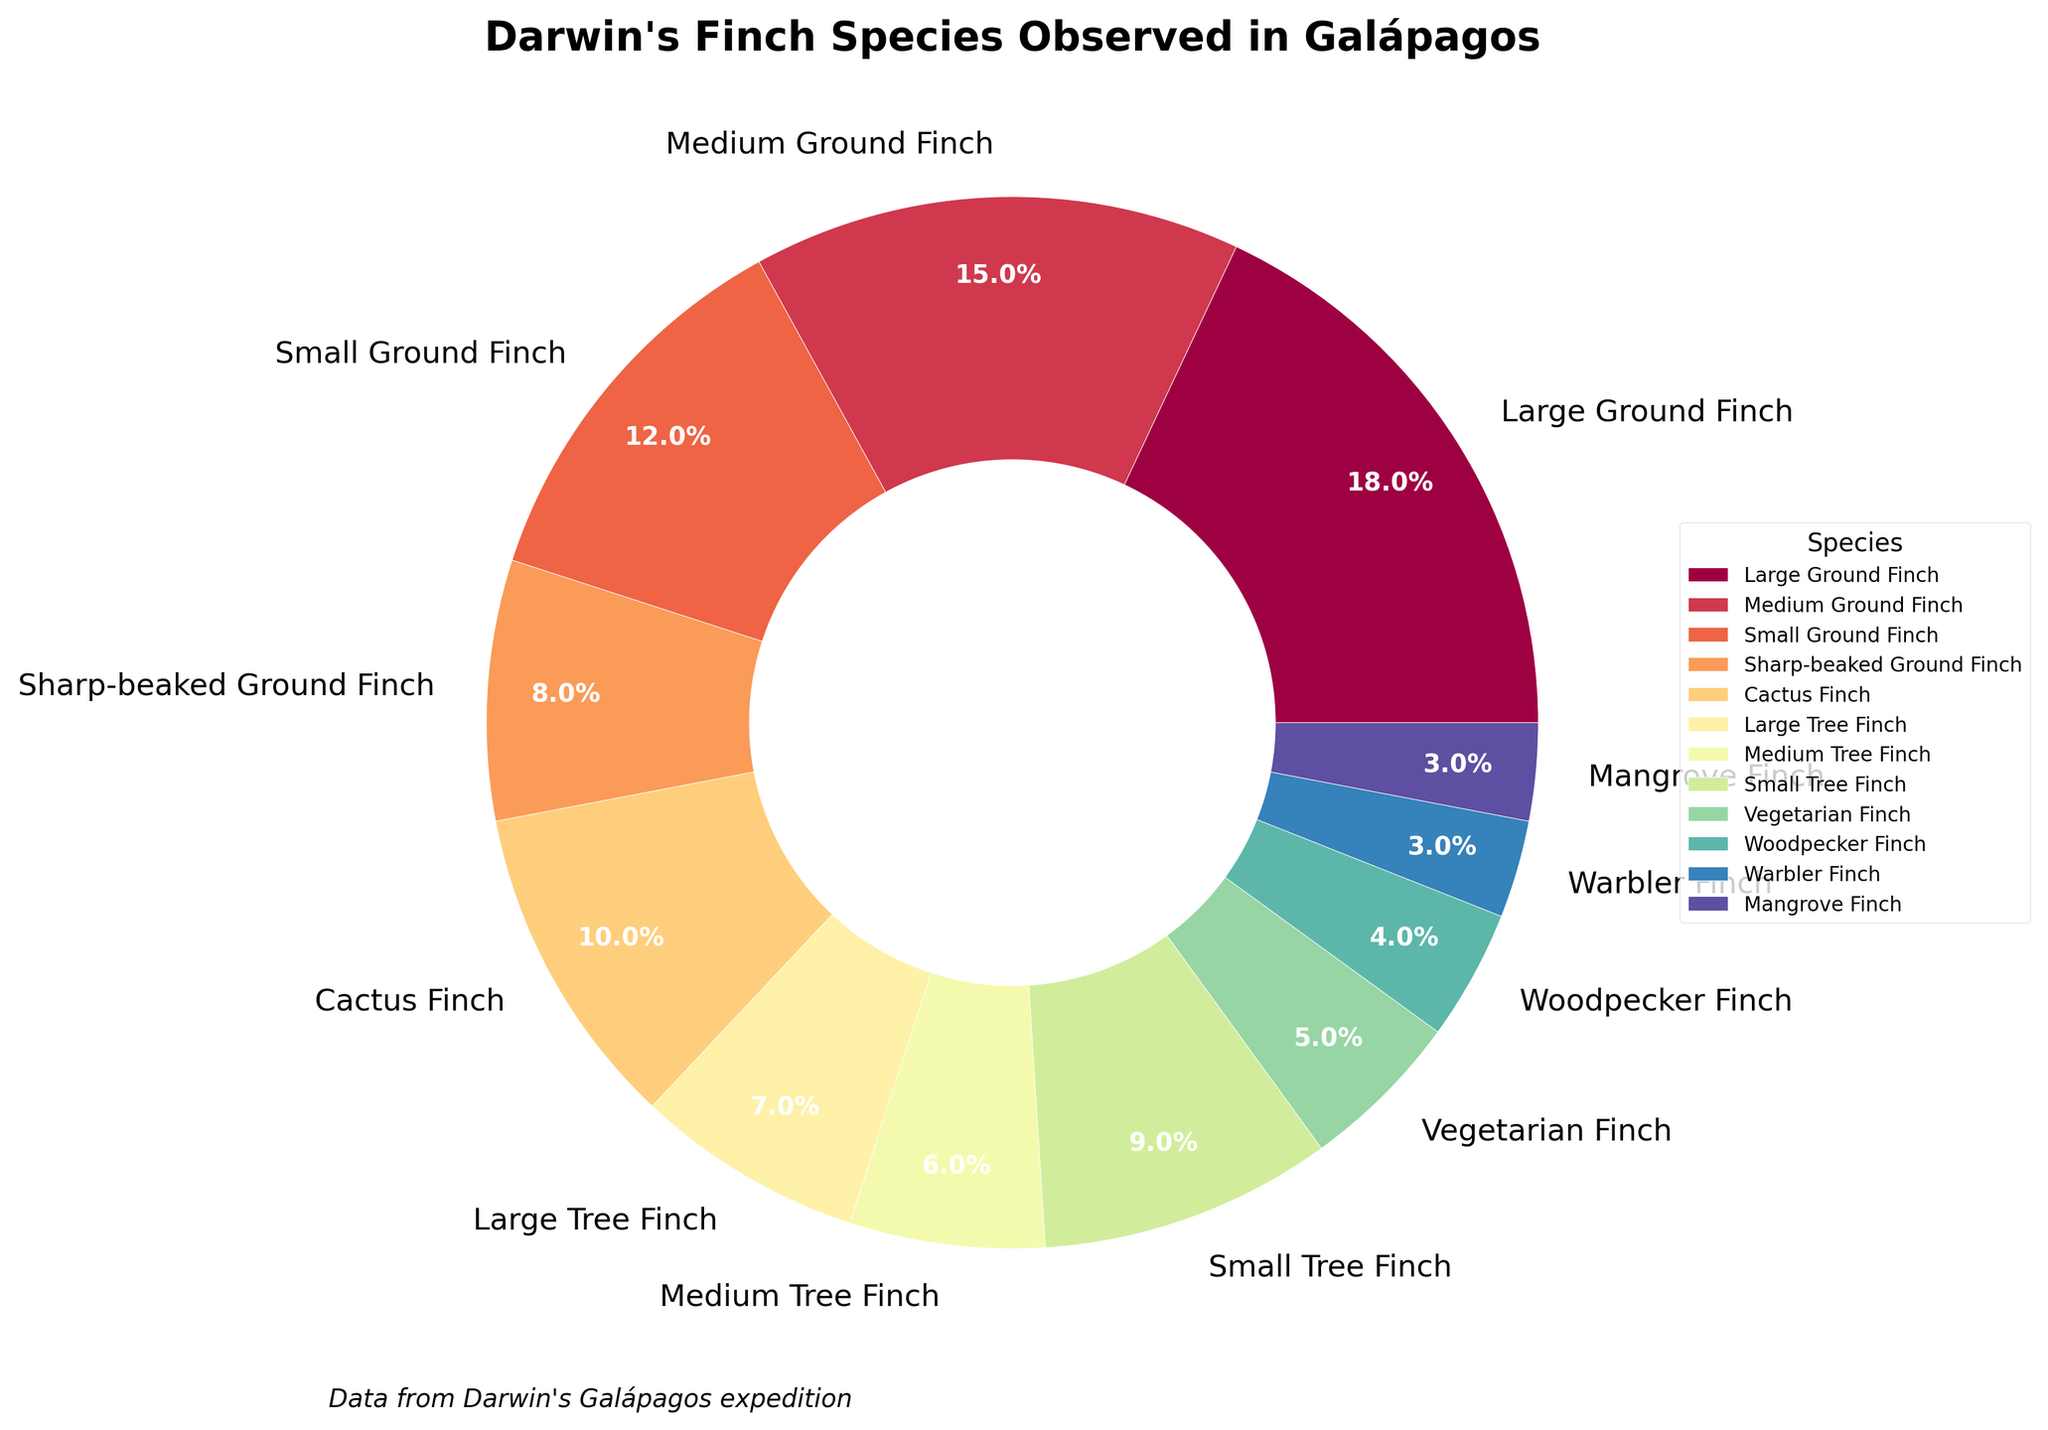What is the percentage of Large Ground Finch observed during the Galápagos expedition? The Large Ground Finch occupies a segment of the pie chart labelled as 18%.
Answer: 18% Which species has the smallest percentage in the chart? The chart shows that the Warbler Finch and Mangrove Finch both occupy the smallest segments, each labelled as 3%.
Answer: Warbler Finch and Mangrove Finch Is the percentage of Medium Ground Finch greater than that of Small Tree Finch? The Medium Ground Finch has a percentage of 15%, while the Small Tree Finch has a percentage of 9%. Since 15% is greater than 9%, the Medium Ground Finch has a higher percentage.
Answer: Yes What is the combined percentage of Large Ground Finch and Medium Ground Finch? The Large Ground Finch is 18% and the Medium Ground Finch is 15%. Adding these together results in 18% + 15% = 33%.
Answer: 33% How much greater is the percentage of Small Ground Finch compared to the percentage of Vegetarian Finch? The Small Ground Finch is 12%, and the Vegetarian Finch is 5%. The difference is calculated as 12% - 5% = 7%.
Answer: 7% Which species group has a percentage closest to the average percentage of all the species? To determine this, we first calculate the average percentage. Summing up all percentages: 18 + 15 + 12 + 8 + 10 + 7 + 6 + 9 + 5 + 4 + 3 + 3 = 100%. With 12 categories, the average percentage is 100% / 12 ≈ 8.33%. The Cactus Finch with 8% is closest to this average.
Answer: Cactus Finch How many species have a percentage higher than the Large Tree Finch? The Large Tree Finch has a percentage of 7%. Checking the chart, the species with higher percentages are Large Ground Finch (18%), Medium Ground Finch (15%), Small Ground Finch (12%), Cactus Finch (10%), and Small Tree Finch (9%). There are 5 such species.
Answer: 5 Are there more species in the Tree Finch or Ground Finch categories? The Ground Finch category includes Large Ground Finch, Medium Ground Finch, Small Ground Finch, and Sharp-beaked Ground Finch (total of 4 species). The Tree Finch category includes Large Tree Finch, Medium Tree Finch, and Small Tree Finch (total of 3 species). Hence, there are more species in the Ground Finch category.
Answer: Ground Finch What is the total percentage of all finch species categorized under Tree Finch? The Tree Finch category includes the Large Tree Finch (7%), Medium Tree Finch (6%), and Small Tree Finch (9%). Adding these together, 7% + 6% + 9% = 22%.
Answer: 22% 